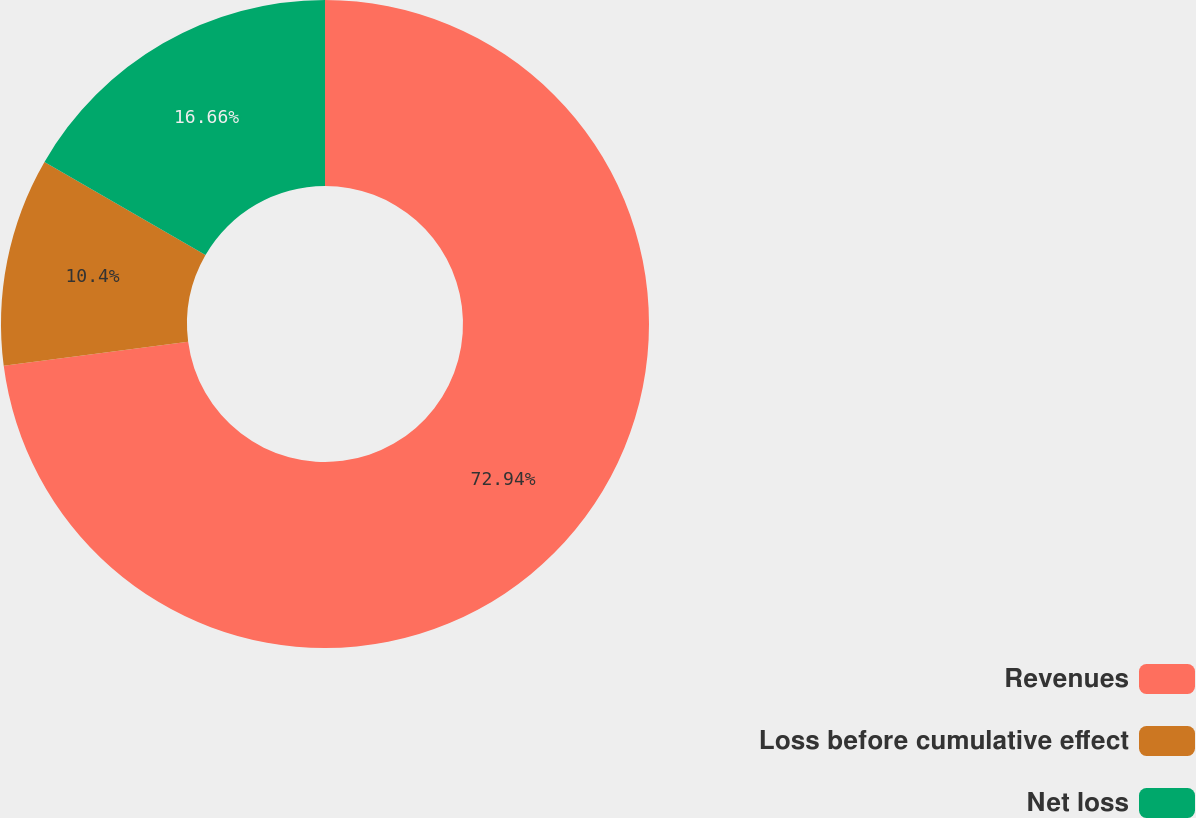Convert chart. <chart><loc_0><loc_0><loc_500><loc_500><pie_chart><fcel>Revenues<fcel>Loss before cumulative effect<fcel>Net loss<nl><fcel>72.94%<fcel>10.4%<fcel>16.66%<nl></chart> 